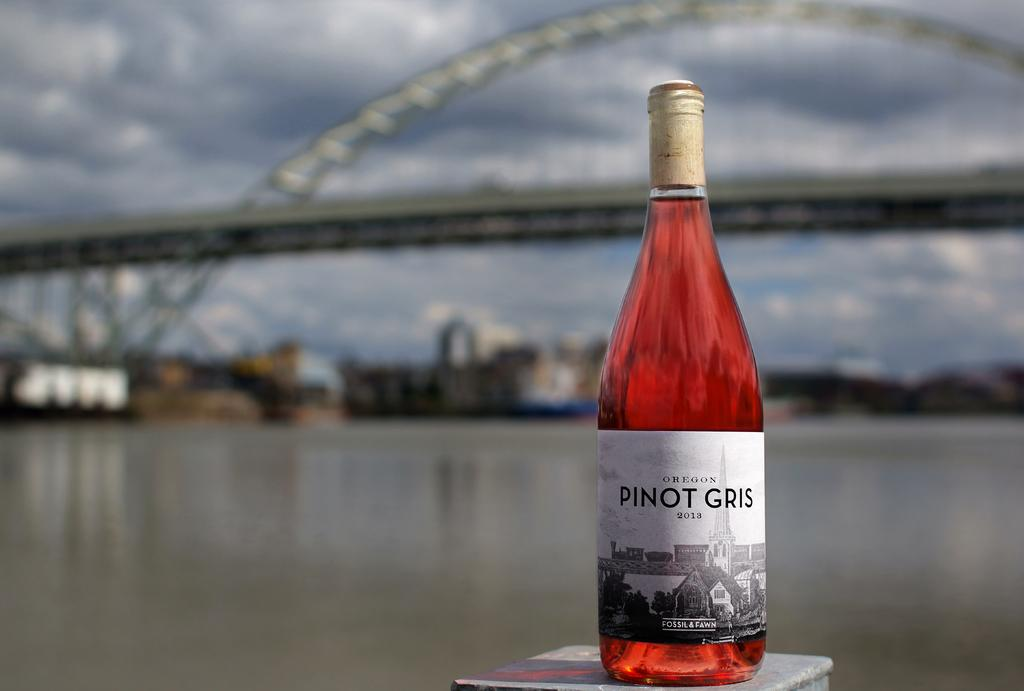<image>
Create a compact narrative representing the image presented. A unopened wine bottle that is names pinot gris. 